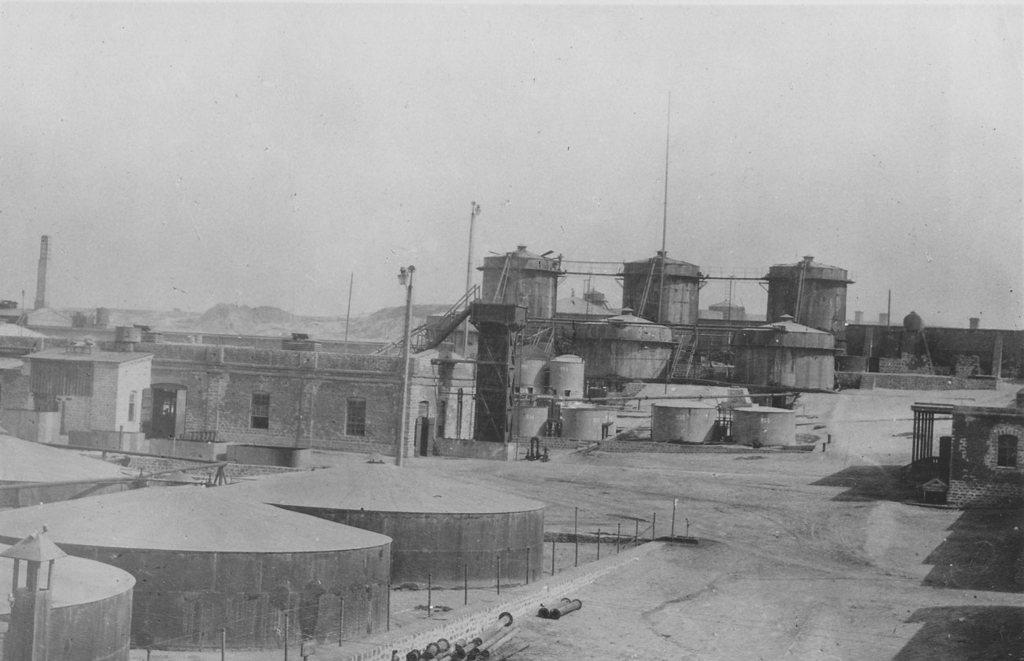What type of picture is in the image? The image contains a black and white picture. What is depicted in the picture? The picture depicts buildings. What else can be seen in the picture besides buildings? The picture includes poles and a footpath. What part of the natural environment is visible in the picture? The sky is visible in the picture. What type of copper material is used to construct the buildings in the image? There is no mention of copper or any specific building material in the image. Can you tell me which actor is walking on the footpath in the image? There is no actor or any person visible in the image; it only shows a footpath and buildings. 